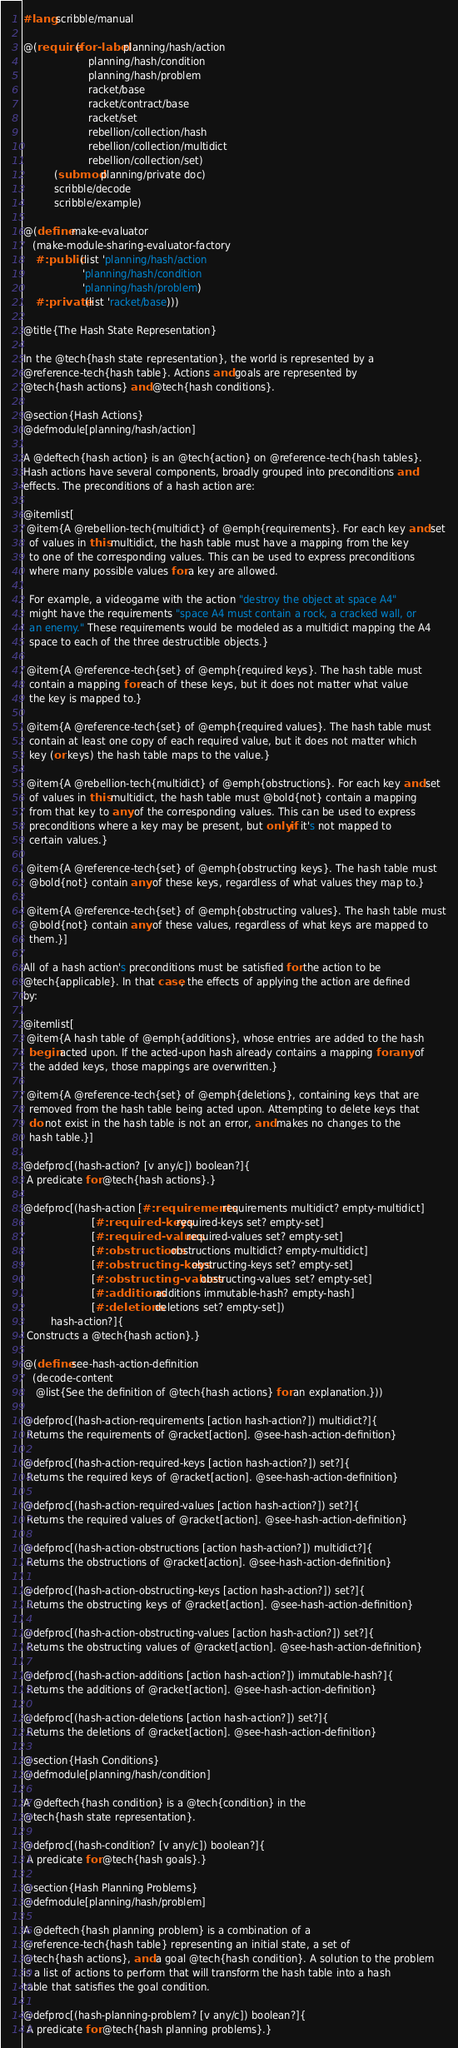Convert code to text. <code><loc_0><loc_0><loc_500><loc_500><_Racket_>#lang scribble/manual

@(require (for-label planning/hash/action
                     planning/hash/condition
                     planning/hash/problem
                     racket/base
                     racket/contract/base
                     racket/set
                     rebellion/collection/hash
                     rebellion/collection/multidict
                     rebellion/collection/set)
          (submod planning/private doc)
          scribble/decode
          scribble/example)

@(define make-evaluator
   (make-module-sharing-evaluator-factory
    #:public (list 'planning/hash/action
                   'planning/hash/condition
                   'planning/hash/problem)
    #:private (list 'racket/base)))

@title{The Hash State Representation}

In the @tech{hash state representation}, the world is represented by a
@reference-tech{hash table}. Actions and goals are represented by
@tech{hash actions} and @tech{hash conditions}.

@section{Hash Actions}
@defmodule[planning/hash/action]

A @deftech{hash action} is an @tech{action} on @reference-tech{hash tables}.
Hash actions have several components, broadly grouped into preconditions and
effects. The preconditions of a hash action are:

@itemlist[
 @item{A @rebellion-tech{multidict} of @emph{requirements}. For each key and set
  of values in this multidict, the hash table must have a mapping from the key
  to one of the corresponding values. This can be used to express preconditions
  where many possible values for a key are allowed.

  For example, a videogame with the action "destroy the object at space A4"
  might have the requirements "space A4 must contain a rock, a cracked wall, or
  an enemy." These requirements would be modeled as a multidict mapping the A4
  space to each of the three destructible objects.}

 @item{A @reference-tech{set} of @emph{required keys}. The hash table must
  contain a mapping for each of these keys, but it does not matter what value
  the key is mapped to.}

 @item{A @reference-tech{set} of @emph{required values}. The hash table must
  contain at least one copy of each required value, but it does not matter which
  key (or keys) the hash table maps to the value.}

 @item{A @rebellion-tech{multidict} of @emph{obstructions}. For each key and set
  of values in this multidict, the hash table must @bold{not} contain a mapping
  from that key to any of the corresponding values. This can be used to express
  preconditions where a key may be present, but only if it's not mapped to
  certain values.}

 @item{A @reference-tech{set} of @emph{obstructing keys}. The hash table must
  @bold{not} contain any of these keys, regardless of what values they map to.}

 @item{A @reference-tech{set} of @emph{obstructing values}. The hash table must
  @bold{not} contain any of these values, regardless of what keys are mapped to
  them.}]

All of a hash action's preconditions must be satisfied for the action to be
@tech{applicable}. In that case, the effects of applying the action are defined
by:

@itemlist[
 @item{A hash table of @emph{additions}, whose entries are added to the hash
  begin acted upon. If the acted-upon hash already contains a mapping for any of
  the added keys, those mappings are overwritten.}

 @item{A @reference-tech{set} of @emph{deletions}, containing keys that are
  removed from the hash table being acted upon. Attempting to delete keys that
  do not exist in the hash table is not an error, and makes no changes to the
  hash table.}]

@defproc[(hash-action? [v any/c]) boolean?]{
 A predicate for @tech{hash actions}.}

@defproc[(hash-action [#:requirements requirements multidict? empty-multidict]
                      [#:required-keys required-keys set? empty-set]
                      [#:required-values required-values set? empty-set]
                      [#:obstructions obstructions multidict? empty-multidict]
                      [#:obstructing-keys obstructing-keys set? empty-set]
                      [#:obstructing-values obstructing-values set? empty-set]
                      [#:additions additions immutable-hash? empty-hash]
                      [#:deletions deletions set? empty-set])
         hash-action?]{
 Constructs a @tech{hash action}.}

@(define see-hash-action-definition
   (decode-content
    @list{See the definition of @tech{hash actions} for an explanation.}))

@defproc[(hash-action-requirements [action hash-action?]) multidict?]{
 Returns the requirements of @racket[action]. @see-hash-action-definition}

@defproc[(hash-action-required-keys [action hash-action?]) set?]{
 Returns the required keys of @racket[action]. @see-hash-action-definition}

@defproc[(hash-action-required-values [action hash-action?]) set?]{
 Returns the required values of @racket[action]. @see-hash-action-definition}

@defproc[(hash-action-obstructions [action hash-action?]) multidict?]{
 Returns the obstructions of @racket[action]. @see-hash-action-definition}

@defproc[(hash-action-obstructing-keys [action hash-action?]) set?]{
 Returns the obstructing keys of @racket[action]. @see-hash-action-definition}

@defproc[(hash-action-obstructing-values [action hash-action?]) set?]{
 Returns the obstructing values of @racket[action]. @see-hash-action-definition}

@defproc[(hash-action-additions [action hash-action?]) immutable-hash?]{
 Returns the additions of @racket[action]. @see-hash-action-definition}

@defproc[(hash-action-deletions [action hash-action?]) set?]{
 Returns the deletions of @racket[action]. @see-hash-action-definition}

@section{Hash Conditions}
@defmodule[planning/hash/condition]

A @deftech{hash condition} is a @tech{condition} in the
@tech{hash state representation}.

@defproc[(hash-condition? [v any/c]) boolean?]{
 A predicate for @tech{hash goals}.}

@section{Hash Planning Problems}
@defmodule[planning/hash/problem]

A @deftech{hash planning problem} is a combination of a
@reference-tech{hash table} representing an initial state, a set of
@tech{hash actions}, and a goal @tech{hash condition}. A solution to the problem
is a list of actions to perform that will transform the hash table into a hash
table that satisfies the goal condition.

@defproc[(hash-planning-problem? [v any/c]) boolean?]{
 A predicate for @tech{hash planning problems}.}
</code> 